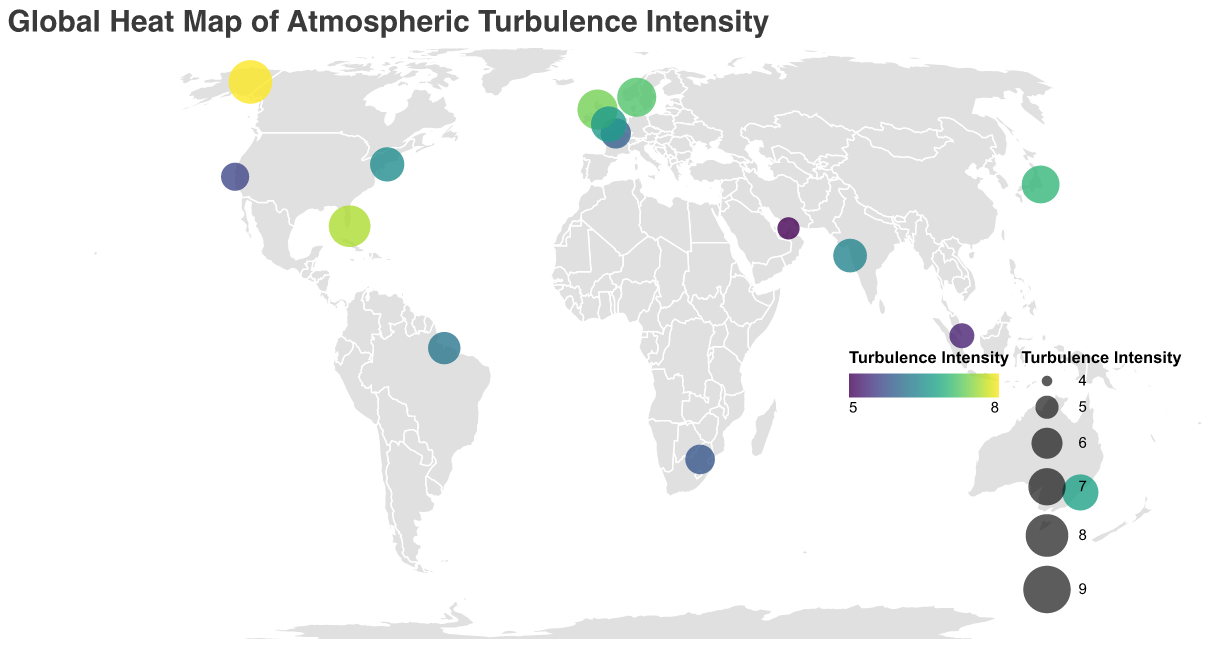What is the title of the figure? The title is typically found at the top of the figure, providing a summary of what the figure represents.
Answer: Global Heat Map of Atmospheric Turbulence Intensity Which region has the highest turbulence intensity? Identifying the highest value in the Turbulence Intensity legend and locating the corresponding region in the tooltip provides the answer.
Answer: Alaska How many regions have a turbulence intensity greater than 7? Count all the data points on the plot where the Turbulence Intensity value, indicated by circle size and color, is greater than 7.
Answer: 5 What is the average turbulence intensity for routes in North Atlantic? North Atlantic has routes New York-London, Glasgow-Reykjavik, and London-New York. Average = (6.5 + 7.5 + 6.7) / 3 = 6.9.
Answer: 6.9 Which route in the South Pacific is affected by atmospheric turbulence? Locate the South Pacific region on the map and check the tooltip for the affected route.
Answer: Sydney-Los Angeles Compare the turbulence intensities between the routes Paris-Dubai and Dubai-Mumbai. Which one is higher? Check the turbulence intensity values from the tooltip for both routes. Paris-Dubai has 5.9 and Dubai-Mumbai has 4.9.
Answer: Paris-Dubai What is the total number of routes with a turbulence intensity below 6? Count all the data points where the Turbulence Intensity value, indicated by circle size and color, is below 6.
Answer: 6 Which regions' routes have a turbulence intensity exactly between 6 and 7? Identify data points where Turbulence Intensity is greater than 6 and less than 7, and check the respective regions in the tooltip.
Answer: North Atlantic, South America, Southern Africa, Indian Ocean, North Pacific What is the most frequent range of turbulence intensity values observed (e.g., intervals like 4-5, 5-6, etc.)? Count the number of data points within specific turbulence intensity ranges and identify the range with the most counts.
Answer: 6-7 Which route has the lowest turbulence intensity and what is its value? Find the smallest value in the Turbulence Intensity legend and locate the corresponding Affected Route in the tooltip.
Answer: Dubai-Mumbai, 4.9 